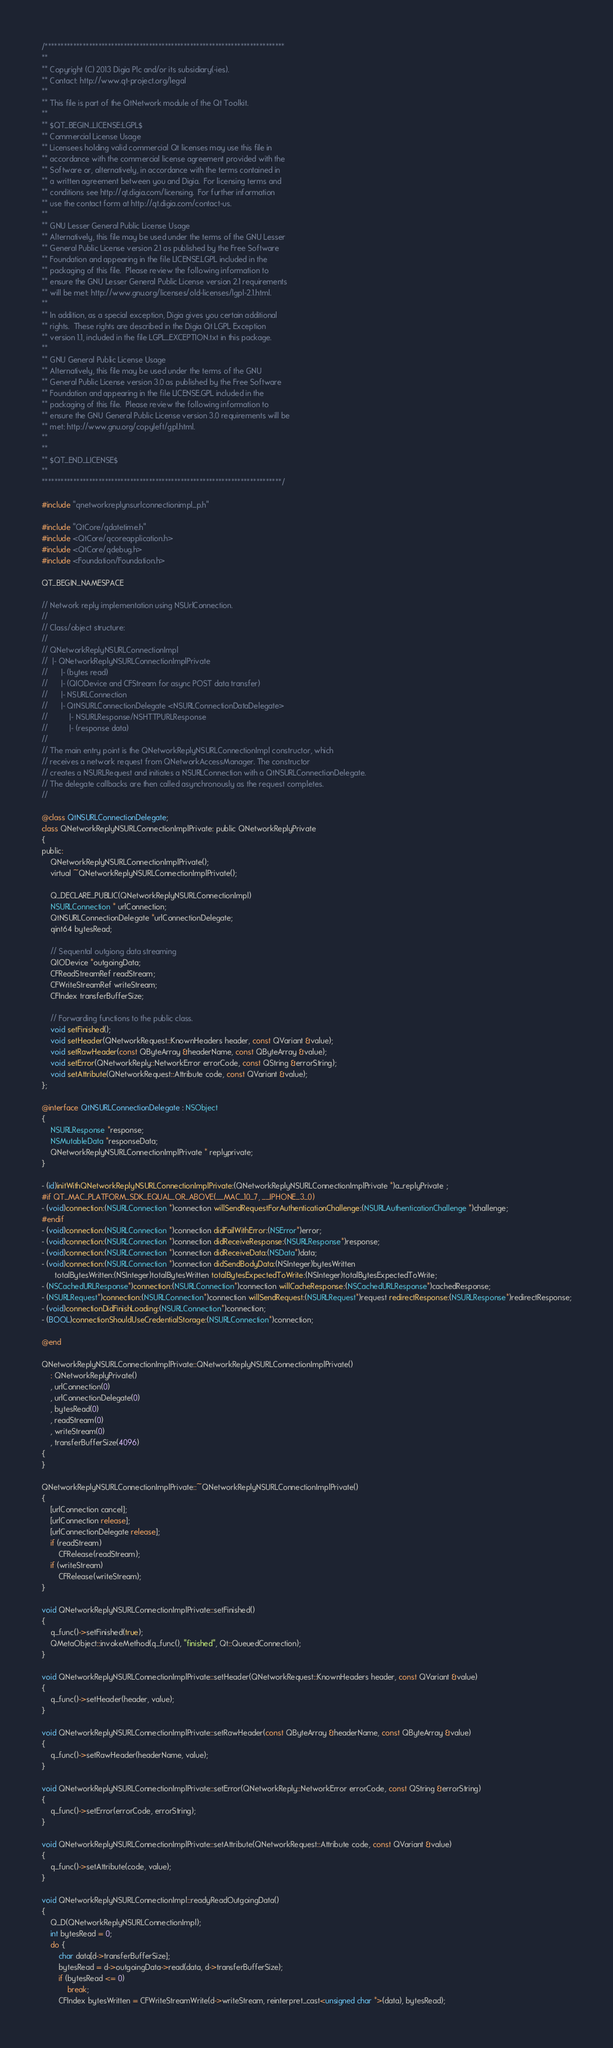Convert code to text. <code><loc_0><loc_0><loc_500><loc_500><_ObjectiveC_>/****************************************************************************
**
** Copyright (C) 2013 Digia Plc and/or its subsidiary(-ies).
** Contact: http://www.qt-project.org/legal
**
** This file is part of the QtNetwork module of the Qt Toolkit.
**
** $QT_BEGIN_LICENSE:LGPL$
** Commercial License Usage
** Licensees holding valid commercial Qt licenses may use this file in
** accordance with the commercial license agreement provided with the
** Software or, alternatively, in accordance with the terms contained in
** a written agreement between you and Digia.  For licensing terms and
** conditions see http://qt.digia.com/licensing.  For further information
** use the contact form at http://qt.digia.com/contact-us.
**
** GNU Lesser General Public License Usage
** Alternatively, this file may be used under the terms of the GNU Lesser
** General Public License version 2.1 as published by the Free Software
** Foundation and appearing in the file LICENSE.LGPL included in the
** packaging of this file.  Please review the following information to
** ensure the GNU Lesser General Public License version 2.1 requirements
** will be met: http://www.gnu.org/licenses/old-licenses/lgpl-2.1.html.
**
** In addition, as a special exception, Digia gives you certain additional
** rights.  These rights are described in the Digia Qt LGPL Exception
** version 1.1, included in the file LGPL_EXCEPTION.txt in this package.
**
** GNU General Public License Usage
** Alternatively, this file may be used under the terms of the GNU
** General Public License version 3.0 as published by the Free Software
** Foundation and appearing in the file LICENSE.GPL included in the
** packaging of this file.  Please review the following information to
** ensure the GNU General Public License version 3.0 requirements will be
** met: http://www.gnu.org/copyleft/gpl.html.
**
**
** $QT_END_LICENSE$
**
****************************************************************************/

#include "qnetworkreplynsurlconnectionimpl_p.h"

#include "QtCore/qdatetime.h"
#include <QtCore/qcoreapplication.h>
#include <QtCore/qdebug.h>
#include <Foundation/Foundation.h>

QT_BEGIN_NAMESPACE

// Network reply implementation using NSUrlConnection.
//
// Class/object structure:
//
// QNetworkReplyNSURLConnectionImpl
//  |- QNetworkReplyNSURLConnectionImplPrivate
//      |- (bytes read)
//      |- (QIODevice and CFStream for async POST data transfer)
//      |- NSURLConnection
//      |- QtNSURLConnectionDelegate <NSURLConnectionDataDelegate>
//          |- NSURLResponse/NSHTTPURLResponse
//          |- (response data)
//
// The main entry point is the QNetworkReplyNSURLConnectionImpl constructor, which
// receives a network request from QNetworkAccessManager. The constructor
// creates a NSURLRequest and initiates a NSURLConnection with a QtNSURLConnectionDelegate.
// The delegate callbacks are then called asynchronously as the request completes.
//

@class QtNSURLConnectionDelegate;
class QNetworkReplyNSURLConnectionImplPrivate: public QNetworkReplyPrivate
{
public:
    QNetworkReplyNSURLConnectionImplPrivate();
    virtual ~QNetworkReplyNSURLConnectionImplPrivate();

    Q_DECLARE_PUBLIC(QNetworkReplyNSURLConnectionImpl)
    NSURLConnection * urlConnection;
    QtNSURLConnectionDelegate *urlConnectionDelegate;
    qint64 bytesRead;

    // Sequental outgiong data streaming
    QIODevice *outgoingData;
    CFReadStreamRef readStream;
    CFWriteStreamRef writeStream;
    CFIndex transferBufferSize;

    // Forwarding functions to the public class.
    void setFinished();
    void setHeader(QNetworkRequest::KnownHeaders header, const QVariant &value);
    void setRawHeader(const QByteArray &headerName, const QByteArray &value);
    void setError(QNetworkReply::NetworkError errorCode, const QString &errorString);
    void setAttribute(QNetworkRequest::Attribute code, const QVariant &value);
};

@interface QtNSURLConnectionDelegate : NSObject
{
    NSURLResponse *response;
    NSMutableData *responseData;
    QNetworkReplyNSURLConnectionImplPrivate * replyprivate;
}

- (id)initWithQNetworkReplyNSURLConnectionImplPrivate:(QNetworkReplyNSURLConnectionImplPrivate *)a_replyPrivate ;
#if QT_MAC_PLATFORM_SDK_EQUAL_OR_ABOVE(__MAC_10_7, __IPHONE_3_0)
- (void)connection:(NSURLConnection *)connection willSendRequestForAuthenticationChallenge:(NSURLAuthenticationChallenge *)challenge;
#endif
- (void)connection:(NSURLConnection *)connection didFailWithError:(NSError*)error;
- (void)connection:(NSURLConnection *)connection didReceiveResponse:(NSURLResponse*)response;
- (void)connection:(NSURLConnection *)connection didReceiveData:(NSData*)data;
- (void)connection:(NSURLConnection *)connection didSendBodyData:(NSInteger)bytesWritten
      totalBytesWritten:(NSInteger)totalBytesWritten totalBytesExpectedToWrite:(NSInteger)totalBytesExpectedToWrite;
- (NSCachedURLResponse*)connection:(NSURLConnection*)connection willCacheResponse:(NSCachedURLResponse*)cachedResponse;
- (NSURLRequest*)connection:(NSURLConnection*)connection willSendRequest:(NSURLRequest*)request redirectResponse:(NSURLResponse*)redirectResponse;
- (void)connectionDidFinishLoading:(NSURLConnection*)connection;
- (BOOL)connectionShouldUseCredentialStorage:(NSURLConnection*)connection;

@end

QNetworkReplyNSURLConnectionImplPrivate::QNetworkReplyNSURLConnectionImplPrivate()
    : QNetworkReplyPrivate()
    , urlConnection(0)
    , urlConnectionDelegate(0)
    , bytesRead(0)
    , readStream(0)
    , writeStream(0)
    , transferBufferSize(4096)
{
}

QNetworkReplyNSURLConnectionImplPrivate::~QNetworkReplyNSURLConnectionImplPrivate()
{
    [urlConnection cancel];
    [urlConnection release];
    [urlConnectionDelegate release];
    if (readStream)
        CFRelease(readStream);
    if (writeStream)
        CFRelease(writeStream);
}

void QNetworkReplyNSURLConnectionImplPrivate::setFinished()
{
    q_func()->setFinished(true);
    QMetaObject::invokeMethod(q_func(), "finished", Qt::QueuedConnection);
}

void QNetworkReplyNSURLConnectionImplPrivate::setHeader(QNetworkRequest::KnownHeaders header, const QVariant &value)
{
    q_func()->setHeader(header, value);
}

void QNetworkReplyNSURLConnectionImplPrivate::setRawHeader(const QByteArray &headerName, const QByteArray &value)
{
    q_func()->setRawHeader(headerName, value);
}

void QNetworkReplyNSURLConnectionImplPrivate::setError(QNetworkReply::NetworkError errorCode, const QString &errorString)
{
    q_func()->setError(errorCode, errorString);
}

void QNetworkReplyNSURLConnectionImplPrivate::setAttribute(QNetworkRequest::Attribute code, const QVariant &value)
{
    q_func()->setAttribute(code, value);
}

void QNetworkReplyNSURLConnectionImpl::readyReadOutgoingData()
{
    Q_D(QNetworkReplyNSURLConnectionImpl);
    int bytesRead = 0;
    do {
        char data[d->transferBufferSize];
        bytesRead = d->outgoingData->read(data, d->transferBufferSize);
        if (bytesRead <= 0)
            break;
        CFIndex bytesWritten = CFWriteStreamWrite(d->writeStream, reinterpret_cast<unsigned char *>(data), bytesRead);</code> 